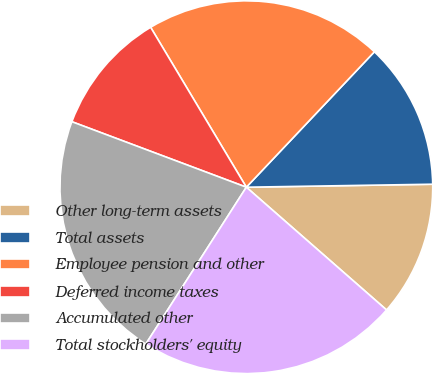<chart> <loc_0><loc_0><loc_500><loc_500><pie_chart><fcel>Other long-term assets<fcel>Total assets<fcel>Employee pension and other<fcel>Deferred income taxes<fcel>Accumulated other<fcel>Total stockholders' equity<nl><fcel>11.7%<fcel>12.69%<fcel>20.64%<fcel>10.7%<fcel>21.64%<fcel>22.63%<nl></chart> 